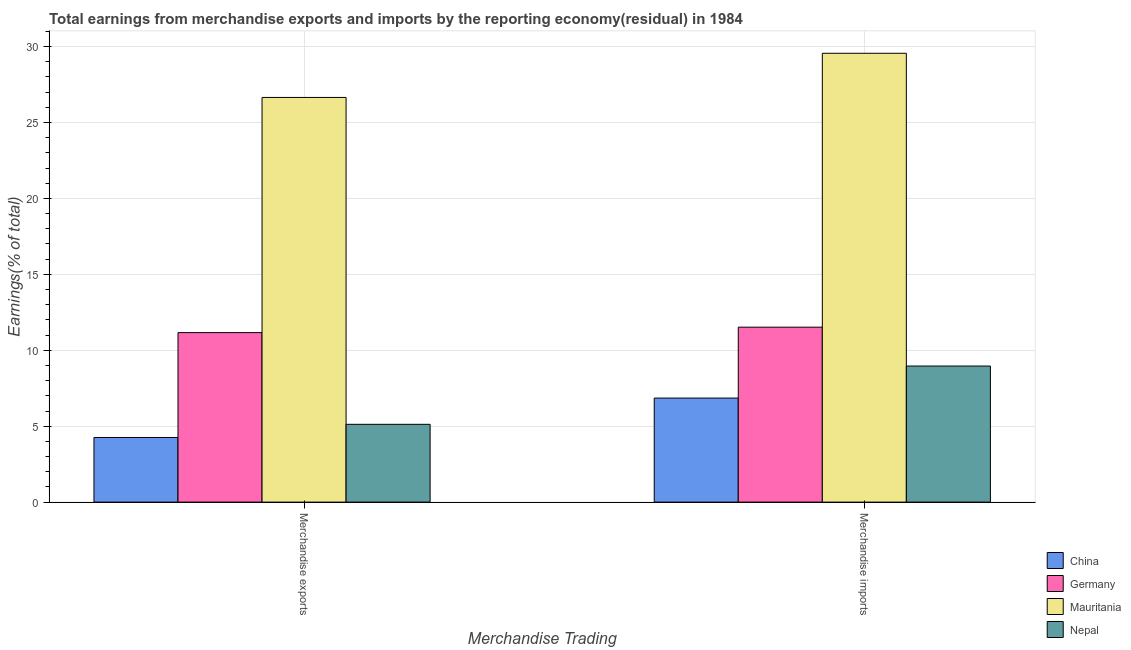How many groups of bars are there?
Offer a very short reply. 2. Are the number of bars per tick equal to the number of legend labels?
Keep it short and to the point. Yes. Are the number of bars on each tick of the X-axis equal?
Offer a terse response. Yes. How many bars are there on the 2nd tick from the right?
Provide a succinct answer. 4. What is the label of the 1st group of bars from the left?
Make the answer very short. Merchandise exports. What is the earnings from merchandise imports in China?
Offer a terse response. 6.85. Across all countries, what is the maximum earnings from merchandise exports?
Provide a succinct answer. 26.65. Across all countries, what is the minimum earnings from merchandise exports?
Provide a short and direct response. 4.26. In which country was the earnings from merchandise imports maximum?
Ensure brevity in your answer.  Mauritania. What is the total earnings from merchandise imports in the graph?
Give a very brief answer. 56.89. What is the difference between the earnings from merchandise exports in Germany and that in Nepal?
Provide a succinct answer. 6.04. What is the difference between the earnings from merchandise imports in Mauritania and the earnings from merchandise exports in Nepal?
Offer a very short reply. 24.43. What is the average earnings from merchandise imports per country?
Your answer should be compact. 14.22. What is the difference between the earnings from merchandise exports and earnings from merchandise imports in Germany?
Ensure brevity in your answer.  -0.36. In how many countries, is the earnings from merchandise imports greater than 8 %?
Offer a terse response. 3. What is the ratio of the earnings from merchandise exports in Nepal to that in Germany?
Give a very brief answer. 0.46. In how many countries, is the earnings from merchandise exports greater than the average earnings from merchandise exports taken over all countries?
Ensure brevity in your answer.  1. What does the 3rd bar from the left in Merchandise exports represents?
Offer a very short reply. Mauritania. What does the 1st bar from the right in Merchandise imports represents?
Offer a very short reply. Nepal. How many bars are there?
Your response must be concise. 8. Are all the bars in the graph horizontal?
Make the answer very short. No. What is the difference between two consecutive major ticks on the Y-axis?
Provide a short and direct response. 5. Are the values on the major ticks of Y-axis written in scientific E-notation?
Provide a short and direct response. No. Does the graph contain any zero values?
Your answer should be compact. No. Where does the legend appear in the graph?
Your answer should be compact. Bottom right. How many legend labels are there?
Offer a very short reply. 4. What is the title of the graph?
Provide a succinct answer. Total earnings from merchandise exports and imports by the reporting economy(residual) in 1984. What is the label or title of the X-axis?
Keep it short and to the point. Merchandise Trading. What is the label or title of the Y-axis?
Give a very brief answer. Earnings(% of total). What is the Earnings(% of total) of China in Merchandise exports?
Provide a succinct answer. 4.26. What is the Earnings(% of total) in Germany in Merchandise exports?
Offer a very short reply. 11.16. What is the Earnings(% of total) in Mauritania in Merchandise exports?
Keep it short and to the point. 26.65. What is the Earnings(% of total) of Nepal in Merchandise exports?
Your answer should be compact. 5.12. What is the Earnings(% of total) of China in Merchandise imports?
Ensure brevity in your answer.  6.85. What is the Earnings(% of total) in Germany in Merchandise imports?
Keep it short and to the point. 11.52. What is the Earnings(% of total) in Mauritania in Merchandise imports?
Your answer should be compact. 29.56. What is the Earnings(% of total) in Nepal in Merchandise imports?
Provide a short and direct response. 8.96. Across all Merchandise Trading, what is the maximum Earnings(% of total) of China?
Your answer should be compact. 6.85. Across all Merchandise Trading, what is the maximum Earnings(% of total) in Germany?
Your response must be concise. 11.52. Across all Merchandise Trading, what is the maximum Earnings(% of total) of Mauritania?
Your response must be concise. 29.56. Across all Merchandise Trading, what is the maximum Earnings(% of total) of Nepal?
Offer a terse response. 8.96. Across all Merchandise Trading, what is the minimum Earnings(% of total) of China?
Keep it short and to the point. 4.26. Across all Merchandise Trading, what is the minimum Earnings(% of total) in Germany?
Keep it short and to the point. 11.16. Across all Merchandise Trading, what is the minimum Earnings(% of total) of Mauritania?
Keep it short and to the point. 26.65. Across all Merchandise Trading, what is the minimum Earnings(% of total) in Nepal?
Offer a very short reply. 5.12. What is the total Earnings(% of total) of China in the graph?
Give a very brief answer. 11.11. What is the total Earnings(% of total) of Germany in the graph?
Your response must be concise. 22.68. What is the total Earnings(% of total) in Mauritania in the graph?
Make the answer very short. 56.21. What is the total Earnings(% of total) in Nepal in the graph?
Your response must be concise. 14.09. What is the difference between the Earnings(% of total) of China in Merchandise exports and that in Merchandise imports?
Your answer should be very brief. -2.59. What is the difference between the Earnings(% of total) in Germany in Merchandise exports and that in Merchandise imports?
Ensure brevity in your answer.  -0.36. What is the difference between the Earnings(% of total) of Mauritania in Merchandise exports and that in Merchandise imports?
Your answer should be very brief. -2.91. What is the difference between the Earnings(% of total) of Nepal in Merchandise exports and that in Merchandise imports?
Your answer should be compact. -3.84. What is the difference between the Earnings(% of total) in China in Merchandise exports and the Earnings(% of total) in Germany in Merchandise imports?
Give a very brief answer. -7.26. What is the difference between the Earnings(% of total) in China in Merchandise exports and the Earnings(% of total) in Mauritania in Merchandise imports?
Ensure brevity in your answer.  -25.3. What is the difference between the Earnings(% of total) of China in Merchandise exports and the Earnings(% of total) of Nepal in Merchandise imports?
Offer a terse response. -4.7. What is the difference between the Earnings(% of total) of Germany in Merchandise exports and the Earnings(% of total) of Mauritania in Merchandise imports?
Your answer should be compact. -18.4. What is the difference between the Earnings(% of total) of Germany in Merchandise exports and the Earnings(% of total) of Nepal in Merchandise imports?
Your answer should be compact. 2.2. What is the difference between the Earnings(% of total) of Mauritania in Merchandise exports and the Earnings(% of total) of Nepal in Merchandise imports?
Make the answer very short. 17.69. What is the average Earnings(% of total) of China per Merchandise Trading?
Offer a terse response. 5.55. What is the average Earnings(% of total) of Germany per Merchandise Trading?
Give a very brief answer. 11.34. What is the average Earnings(% of total) in Mauritania per Merchandise Trading?
Give a very brief answer. 28.1. What is the average Earnings(% of total) of Nepal per Merchandise Trading?
Provide a short and direct response. 7.04. What is the difference between the Earnings(% of total) in China and Earnings(% of total) in Germany in Merchandise exports?
Give a very brief answer. -6.9. What is the difference between the Earnings(% of total) of China and Earnings(% of total) of Mauritania in Merchandise exports?
Ensure brevity in your answer.  -22.39. What is the difference between the Earnings(% of total) in China and Earnings(% of total) in Nepal in Merchandise exports?
Give a very brief answer. -0.87. What is the difference between the Earnings(% of total) in Germany and Earnings(% of total) in Mauritania in Merchandise exports?
Your response must be concise. -15.49. What is the difference between the Earnings(% of total) in Germany and Earnings(% of total) in Nepal in Merchandise exports?
Your response must be concise. 6.04. What is the difference between the Earnings(% of total) in Mauritania and Earnings(% of total) in Nepal in Merchandise exports?
Your answer should be very brief. 21.53. What is the difference between the Earnings(% of total) in China and Earnings(% of total) in Germany in Merchandise imports?
Give a very brief answer. -4.67. What is the difference between the Earnings(% of total) in China and Earnings(% of total) in Mauritania in Merchandise imports?
Ensure brevity in your answer.  -22.71. What is the difference between the Earnings(% of total) of China and Earnings(% of total) of Nepal in Merchandise imports?
Your response must be concise. -2.11. What is the difference between the Earnings(% of total) in Germany and Earnings(% of total) in Mauritania in Merchandise imports?
Provide a short and direct response. -18.04. What is the difference between the Earnings(% of total) in Germany and Earnings(% of total) in Nepal in Merchandise imports?
Your response must be concise. 2.56. What is the difference between the Earnings(% of total) in Mauritania and Earnings(% of total) in Nepal in Merchandise imports?
Your answer should be compact. 20.6. What is the ratio of the Earnings(% of total) of China in Merchandise exports to that in Merchandise imports?
Offer a very short reply. 0.62. What is the ratio of the Earnings(% of total) of Germany in Merchandise exports to that in Merchandise imports?
Your answer should be very brief. 0.97. What is the ratio of the Earnings(% of total) in Mauritania in Merchandise exports to that in Merchandise imports?
Provide a short and direct response. 0.9. What is the ratio of the Earnings(% of total) of Nepal in Merchandise exports to that in Merchandise imports?
Ensure brevity in your answer.  0.57. What is the difference between the highest and the second highest Earnings(% of total) in China?
Provide a succinct answer. 2.59. What is the difference between the highest and the second highest Earnings(% of total) in Germany?
Give a very brief answer. 0.36. What is the difference between the highest and the second highest Earnings(% of total) of Mauritania?
Offer a terse response. 2.91. What is the difference between the highest and the second highest Earnings(% of total) in Nepal?
Give a very brief answer. 3.84. What is the difference between the highest and the lowest Earnings(% of total) of China?
Keep it short and to the point. 2.59. What is the difference between the highest and the lowest Earnings(% of total) of Germany?
Provide a short and direct response. 0.36. What is the difference between the highest and the lowest Earnings(% of total) in Mauritania?
Your answer should be very brief. 2.91. What is the difference between the highest and the lowest Earnings(% of total) of Nepal?
Your response must be concise. 3.84. 